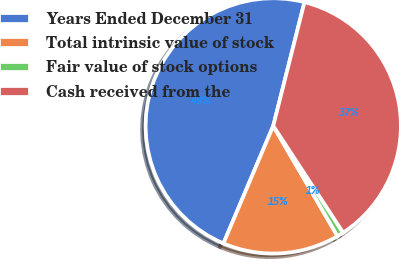<chart> <loc_0><loc_0><loc_500><loc_500><pie_chart><fcel>Years Ended December 31<fcel>Total intrinsic value of stock<fcel>Fair value of stock options<fcel>Cash received from the<nl><fcel>47.56%<fcel>14.78%<fcel>0.83%<fcel>36.84%<nl></chart> 